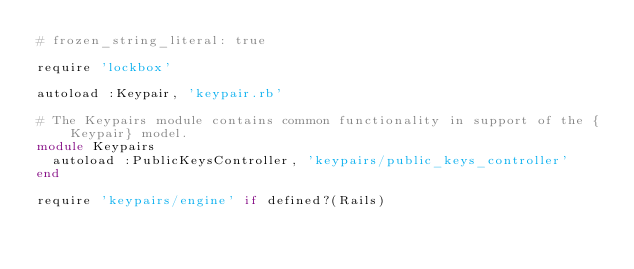<code> <loc_0><loc_0><loc_500><loc_500><_Ruby_># frozen_string_literal: true

require 'lockbox'

autoload :Keypair, 'keypair.rb'

# The Keypairs module contains common functionality in support of the {Keypair} model.
module Keypairs
  autoload :PublicKeysController, 'keypairs/public_keys_controller'
end

require 'keypairs/engine' if defined?(Rails)
</code> 